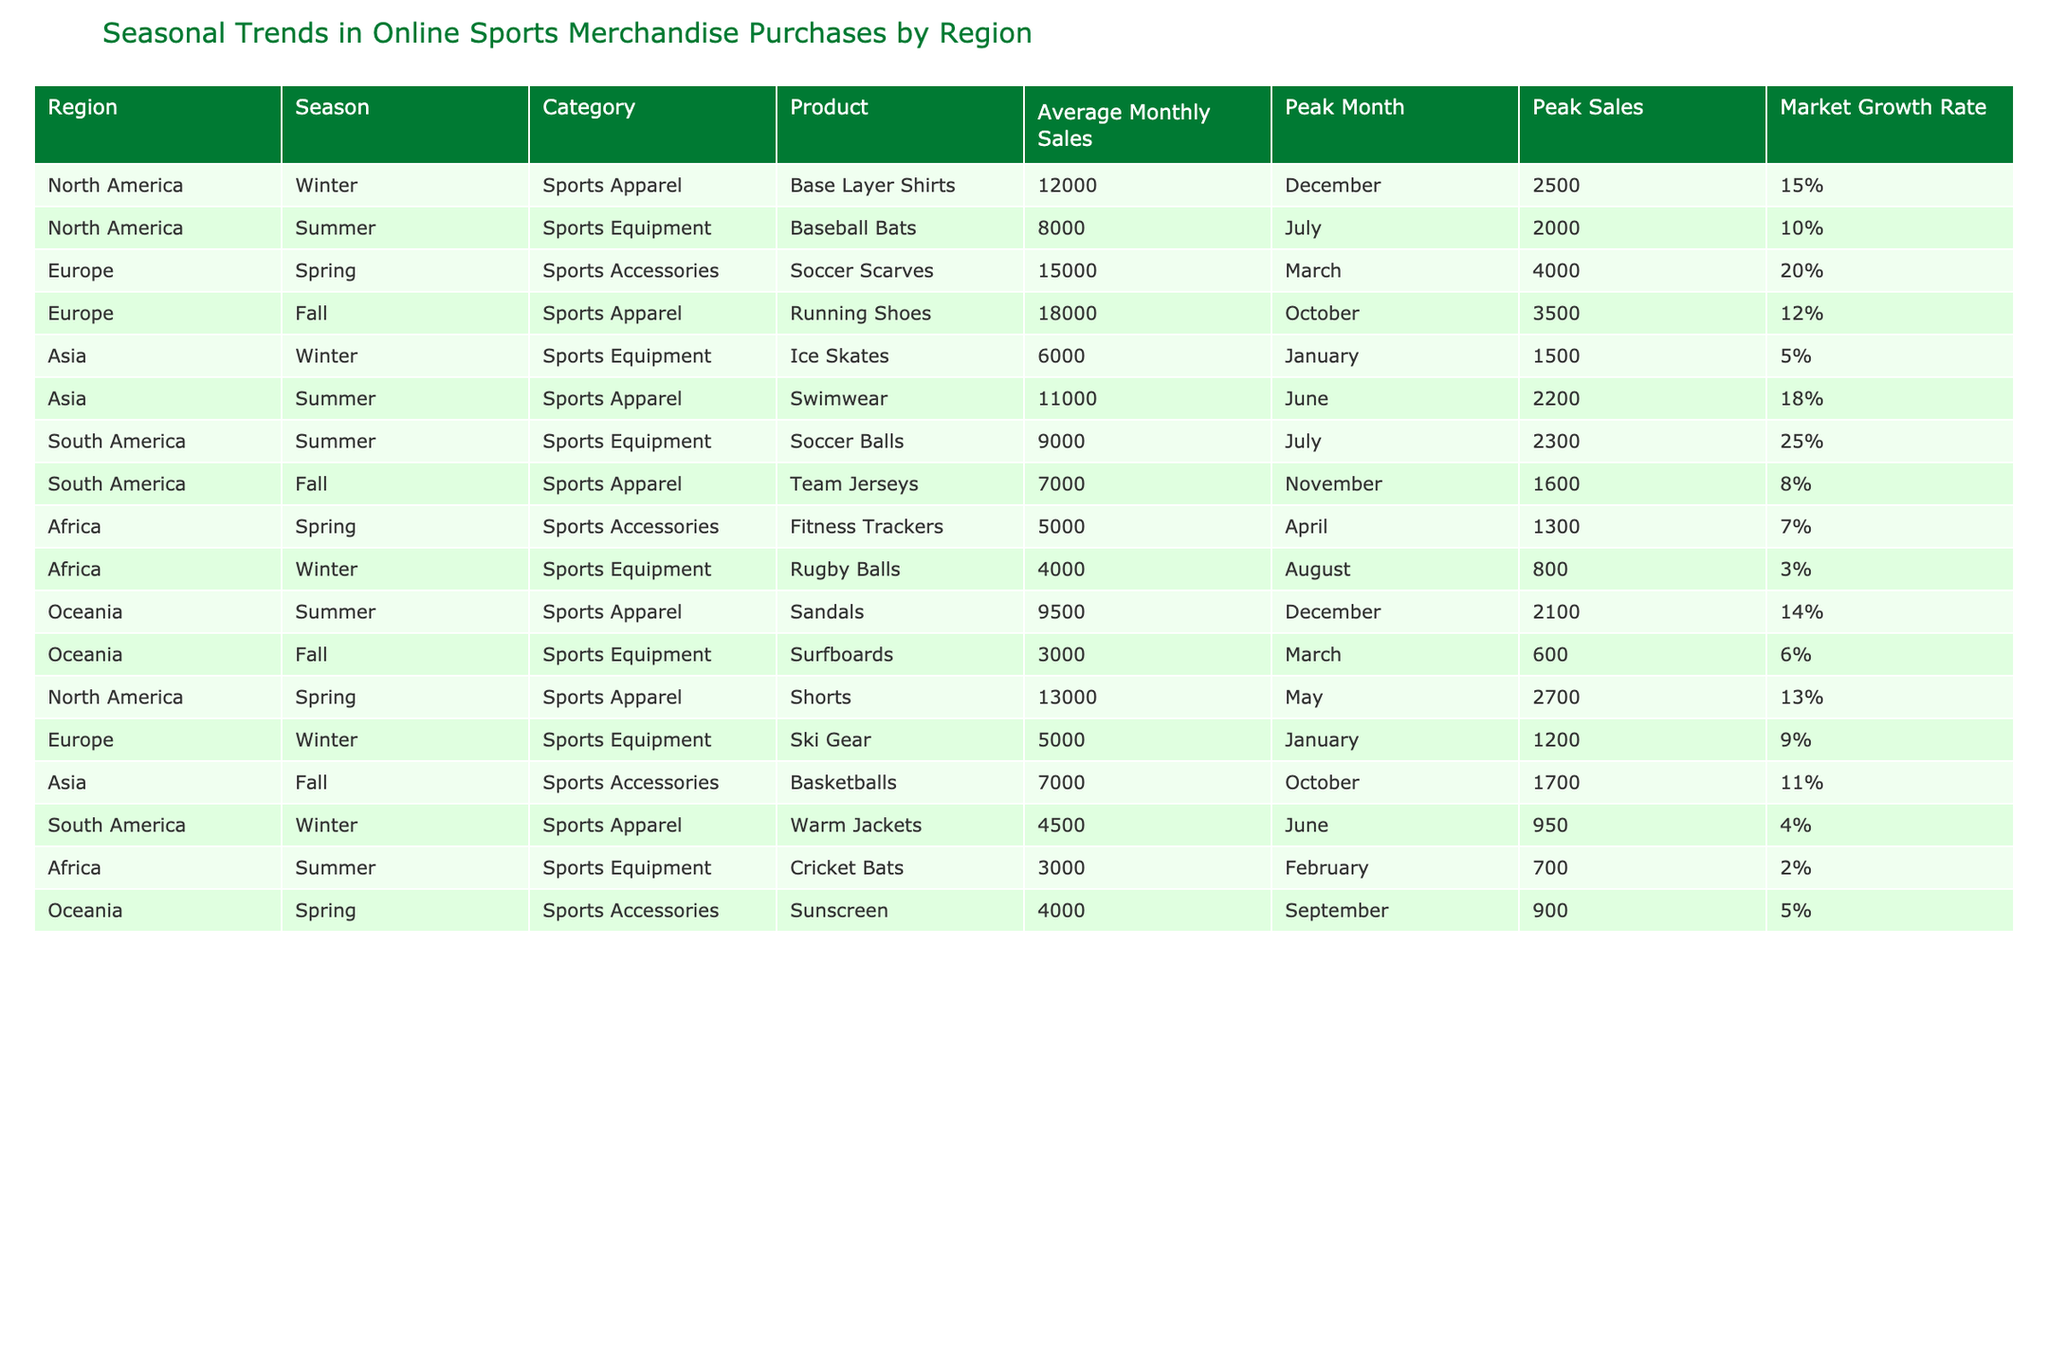What is the peak sales month for Soccer Scarves in Europe? According to the table, the peak sales month for Soccer Scarves in Europe is March.
Answer: March Which region has the highest average monthly sales for sports apparel in Winter? In Winter, North America has the highest average monthly sales for sports apparel, specifically for Base Layer Shirts, with 12000 sales.
Answer: North America What is the total average monthly sales for sports equipment in South America? The average monthly sales for sports equipment in South America includes Soccer Balls (9000) and the peak sales month in July, and Rugby Balls (3000) with peak month being August. Adding them gives 9000 + 3000 = 12000.
Answer: 12000 Is there a category for sports accessories that has a growth rate above 10%? Yes, the Soccer Scarves in Europe have an average growth rate of 20%, which is above 10%.
Answer: Yes In which season do the highest sales for Team Jerseys occur in South America? The peak sales for Team Jerseys occur in the Fall season in South America, with peak sales of 1600 and average monthly sales of 7000.
Answer: Fall What is the average monthly sales for sports apparel in Asia during Summer? For Asia in Summer, the average monthly sales for sports apparel is 11000 for Swimwear.
Answer: 11000 Which product in Africa has the lowest average monthly sales? According to the table, Rugby Balls in Africa have the lowest average monthly sales at 4000.
Answer: Rugby Balls Calculate the difference in average monthly sales between the best-selling sports equipment and sports apparel in Oceania during Summer. In Oceania during Summer, sports apparel (Sandals) average monthly sales are 9500, while sports equipment (Surfboards) average monthly sales are 3000. The difference is 9500 - 3000 = 6500.
Answer: 6500 Which region has the lowest market growth rate for sports equipment? The region with the lowest market growth rate for sports equipment is Africa with a rate of 3%.
Answer: Africa 